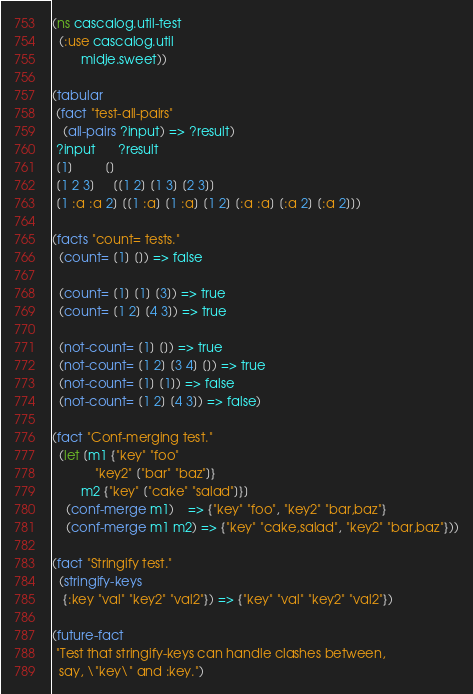<code> <loc_0><loc_0><loc_500><loc_500><_Clojure_>(ns cascalog.util-test
  (:use cascalog.util
        midje.sweet))

(tabular
 (fact "test-all-pairs"
   (all-pairs ?input) => ?result)
 ?input      ?result
 [1]         []
 [1 2 3]     [[1 2] [1 3] [2 3]]
 [1 :a :a 2] [[1 :a] [1 :a] [1 2] [:a :a] [:a 2] [:a 2]])

(facts "count= tests."
  (count= [1] []) => false
  
  (count= [1] [1] [3]) => true 
  (count= [1 2] [4 3]) => true 

  (not-count= [1] []) => true 
  (not-count= [1 2] [3 4] []) => true 
  (not-count= [1] [1]) => false
  (not-count= [1 2] [4 3]) => false)

(fact "Conf-merging test."
  (let [m1 {"key" "foo"
            "key2" ["bar" "baz"]}
        m2 {"key" ["cake" "salad"]}]
    (conf-merge m1)    => {"key" "foo", "key2" "bar,baz"}
    (conf-merge m1 m2) => {"key" "cake,salad", "key2" "bar,baz"}))

(fact "Stringify test."
  (stringify-keys
   {:key "val" "key2" "val2"}) => {"key" "val" "key2" "val2"})

(future-fact
 "Test that stringify-keys can handle clashes between,
  say, \"key\" and :key.")
</code> 